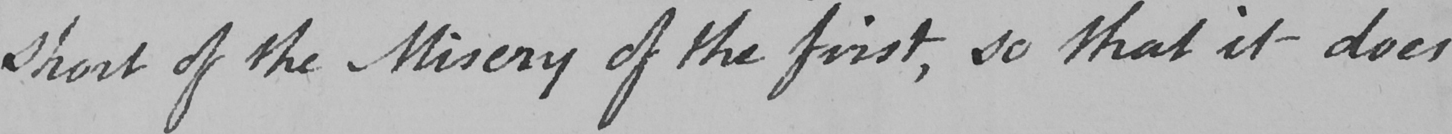What does this handwritten line say? short of the Misery of the first , so that it does 